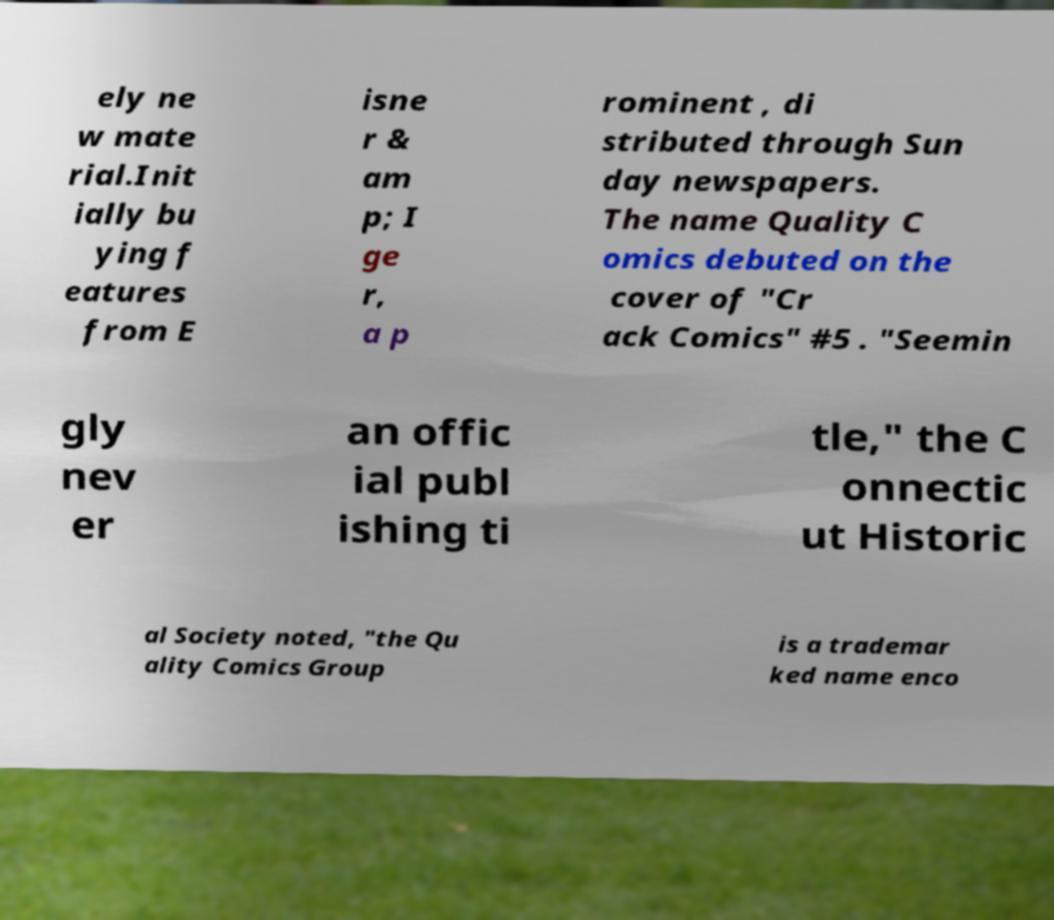Please read and relay the text visible in this image. What does it say? ely ne w mate rial.Init ially bu ying f eatures from E isne r & am p; I ge r, a p rominent , di stributed through Sun day newspapers. The name Quality C omics debuted on the cover of "Cr ack Comics" #5 . "Seemin gly nev er an offic ial publ ishing ti tle," the C onnectic ut Historic al Society noted, "the Qu ality Comics Group is a trademar ked name enco 